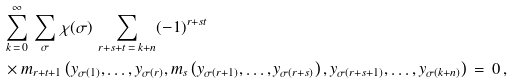<formula> <loc_0><loc_0><loc_500><loc_500>& \sum _ { k \, = \, 0 } ^ { \infty } \, \sum _ { \sigma } \, \chi ( \sigma ) \, \sum _ { r + s + t \, = \, k + n } ( - 1 ) ^ { r + s t } \, \\ & \times m _ { r + t + 1 } \left ( y _ { \sigma ( 1 ) } , \dots , y _ { \sigma ( r ) } , m _ { s } \left ( y _ { \sigma ( r + 1 ) } , \dots , y _ { \sigma ( r + s ) } \right ) , y _ { \sigma ( r + s + 1 ) } , \dots , y _ { \sigma ( k + n ) } \right ) \, = \, 0 \, ,</formula> 